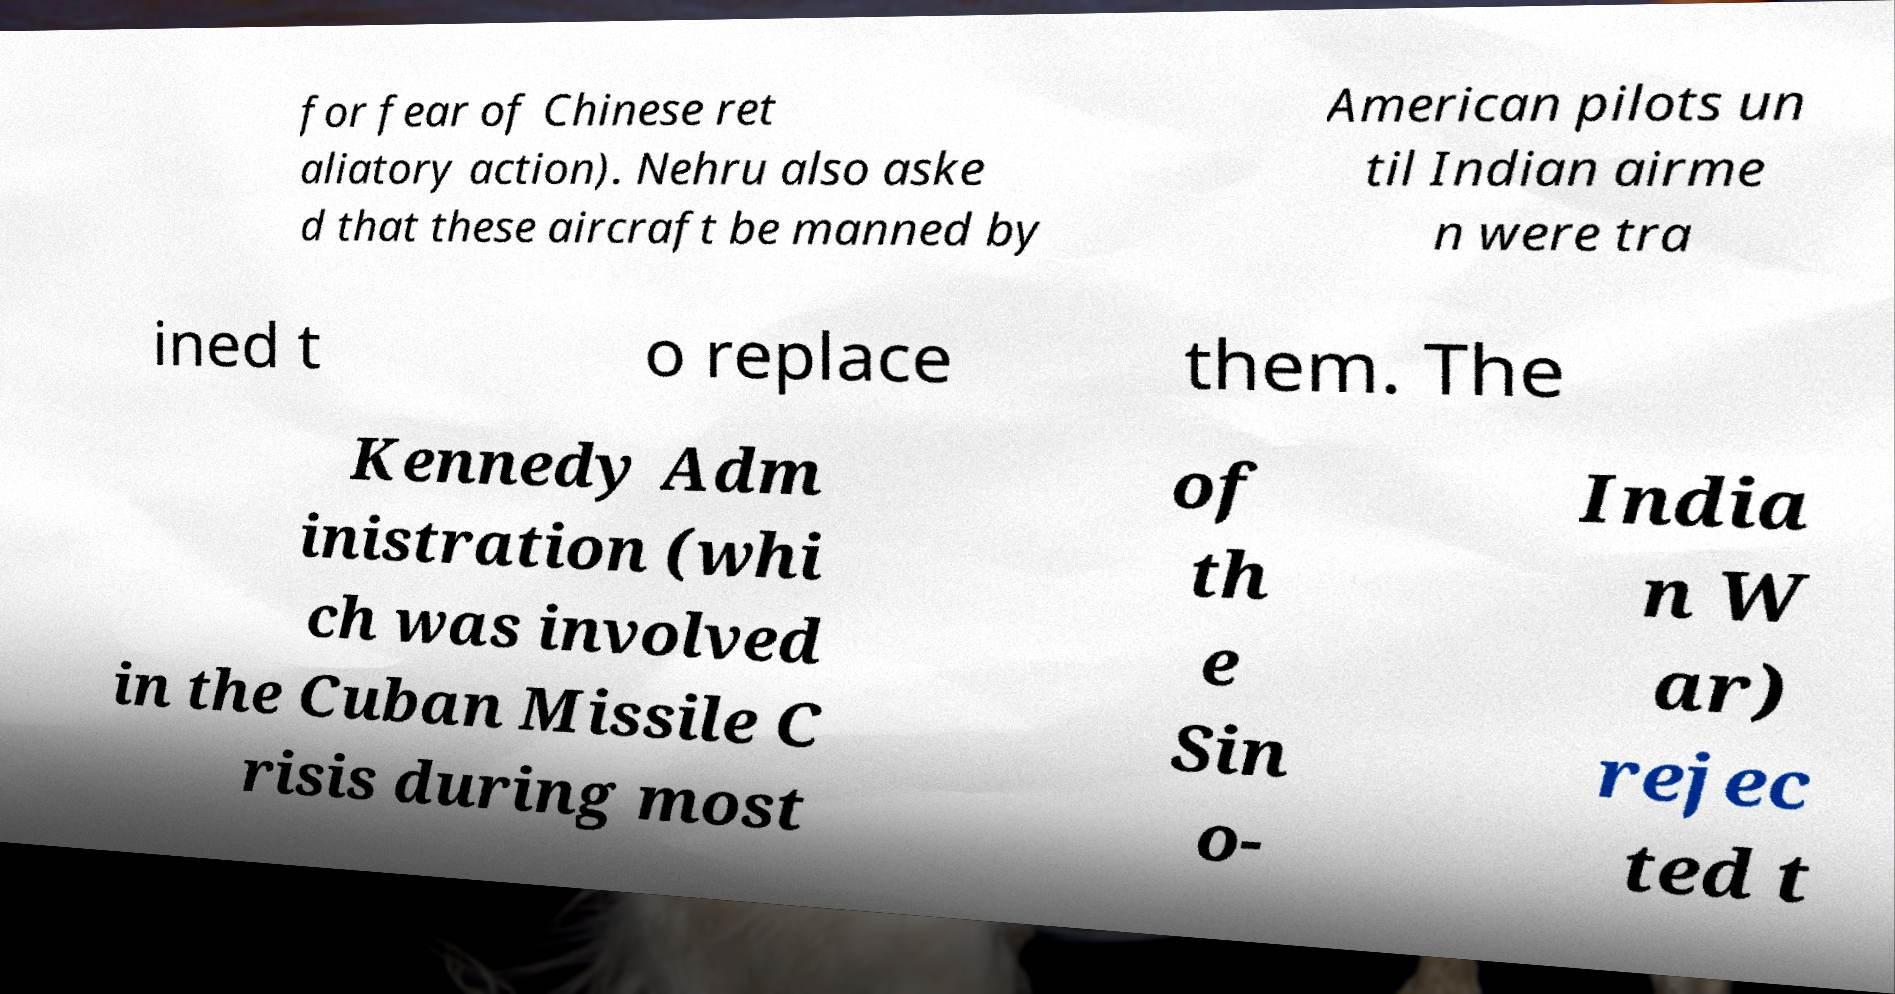I need the written content from this picture converted into text. Can you do that? for fear of Chinese ret aliatory action). Nehru also aske d that these aircraft be manned by American pilots un til Indian airme n were tra ined t o replace them. The Kennedy Adm inistration (whi ch was involved in the Cuban Missile C risis during most of th e Sin o- India n W ar) rejec ted t 